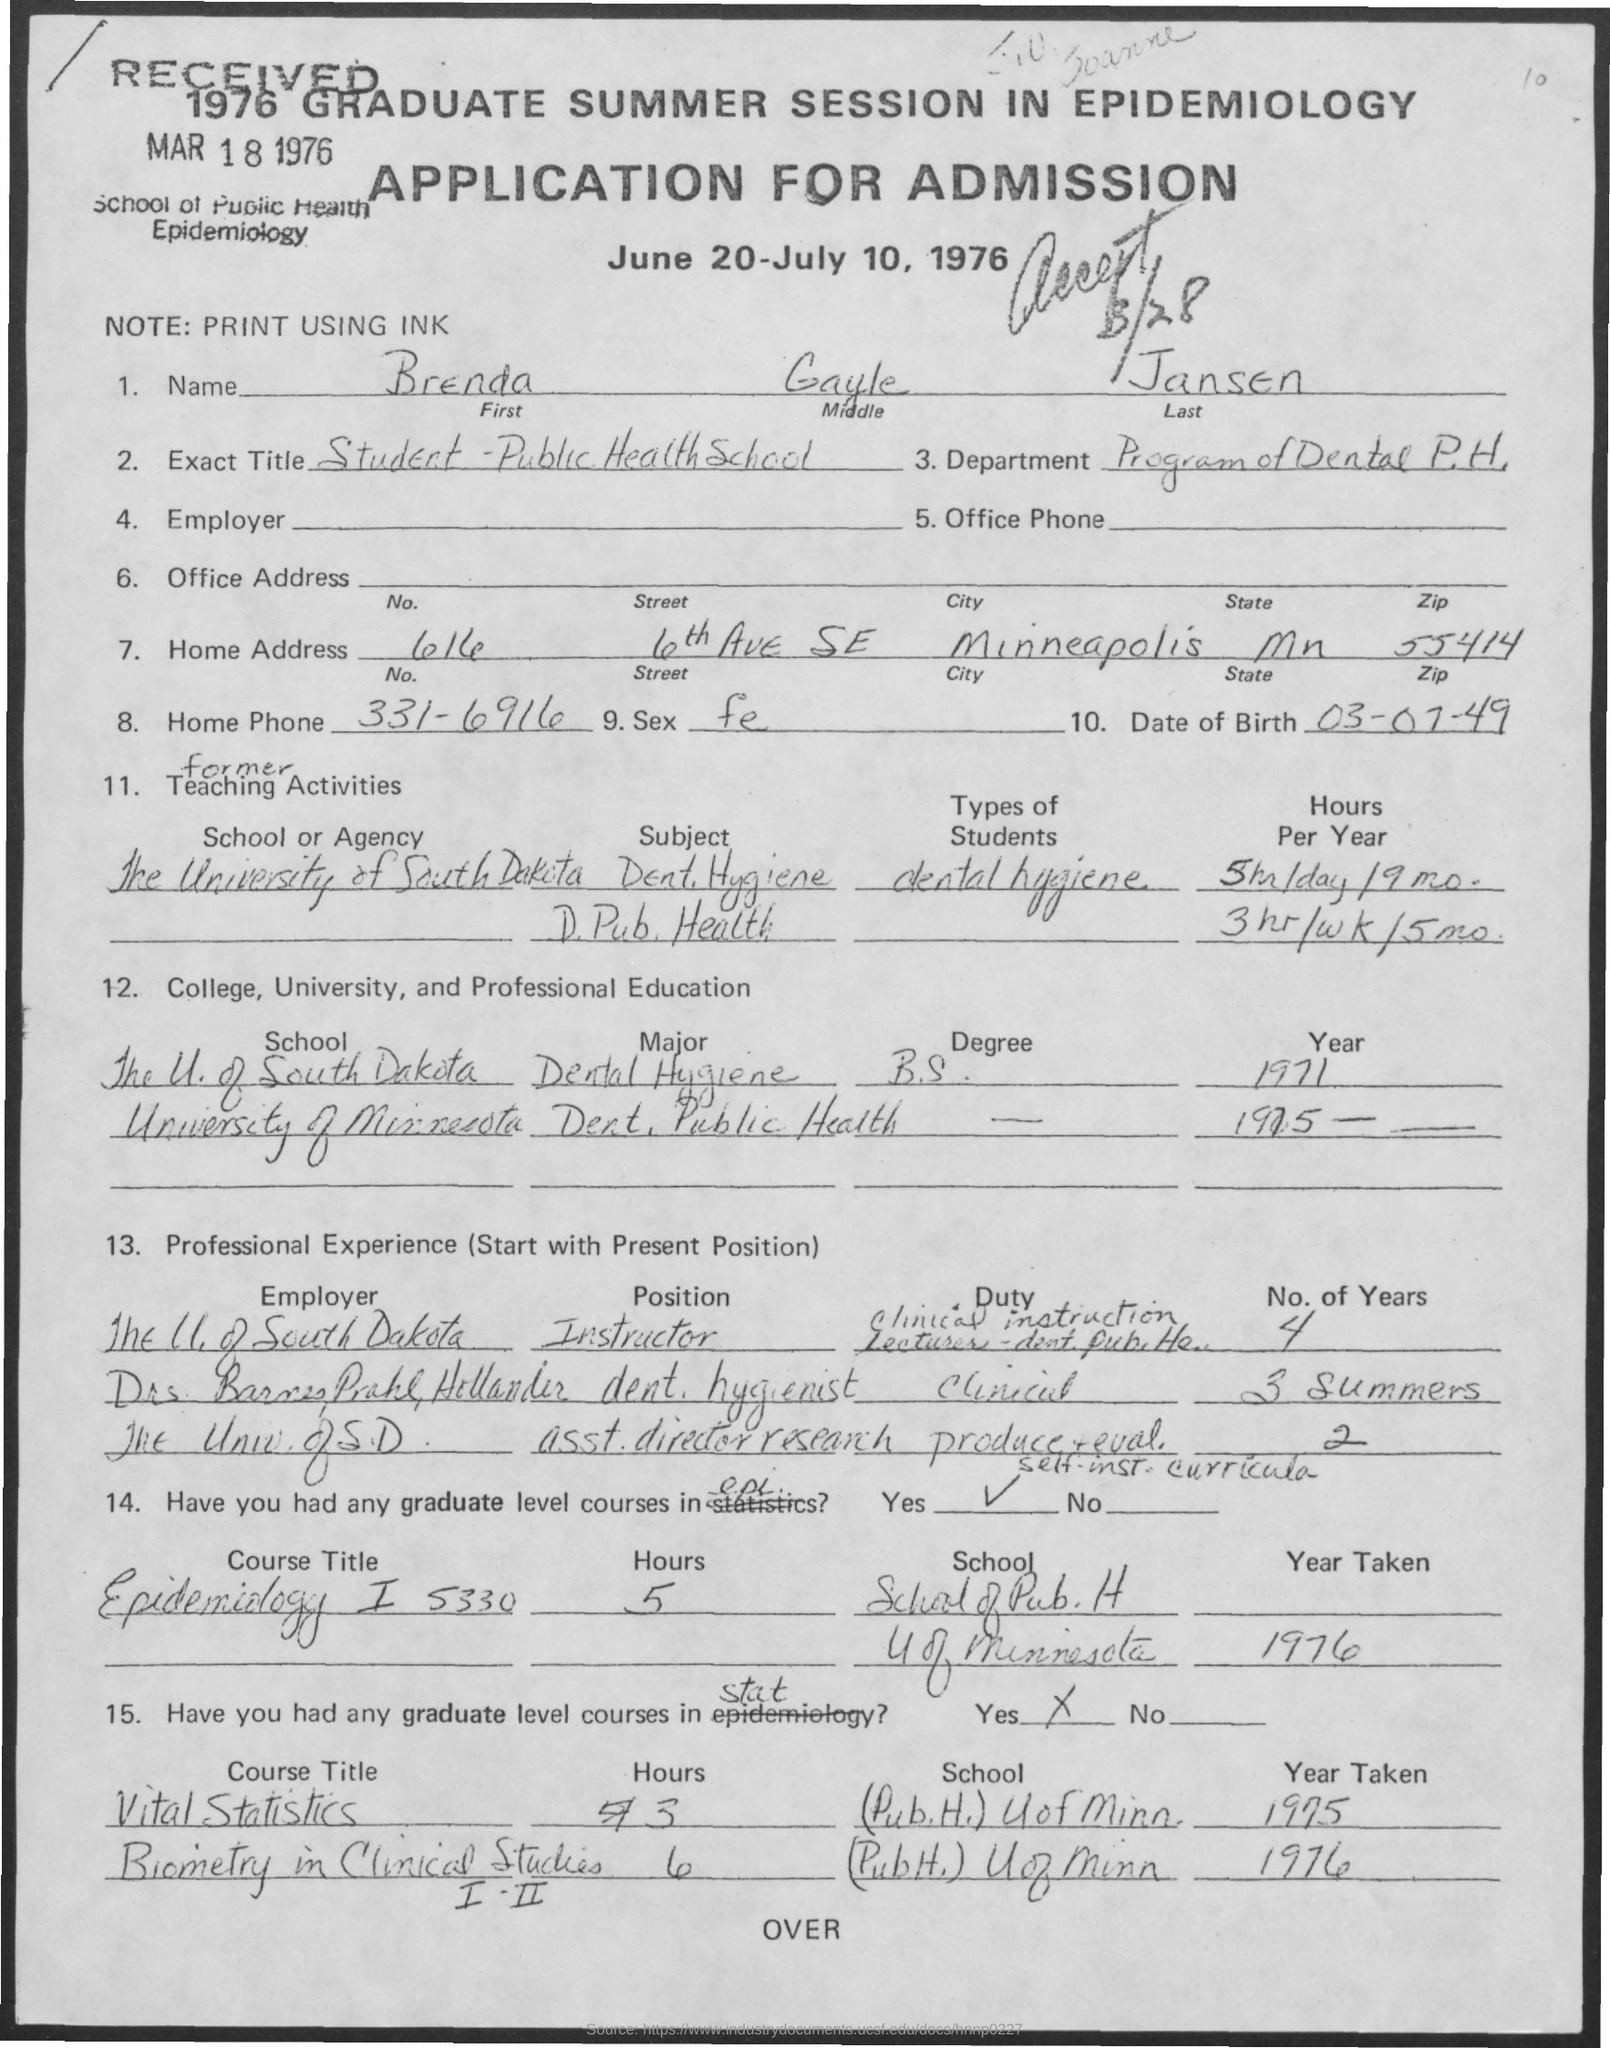Mention a couple of crucial points in this snapshot. The zip code is 55414. The middle name is Gayle. The program in Dental Public Health is the department. The city is Minneapolis. The state is Minnesota. 